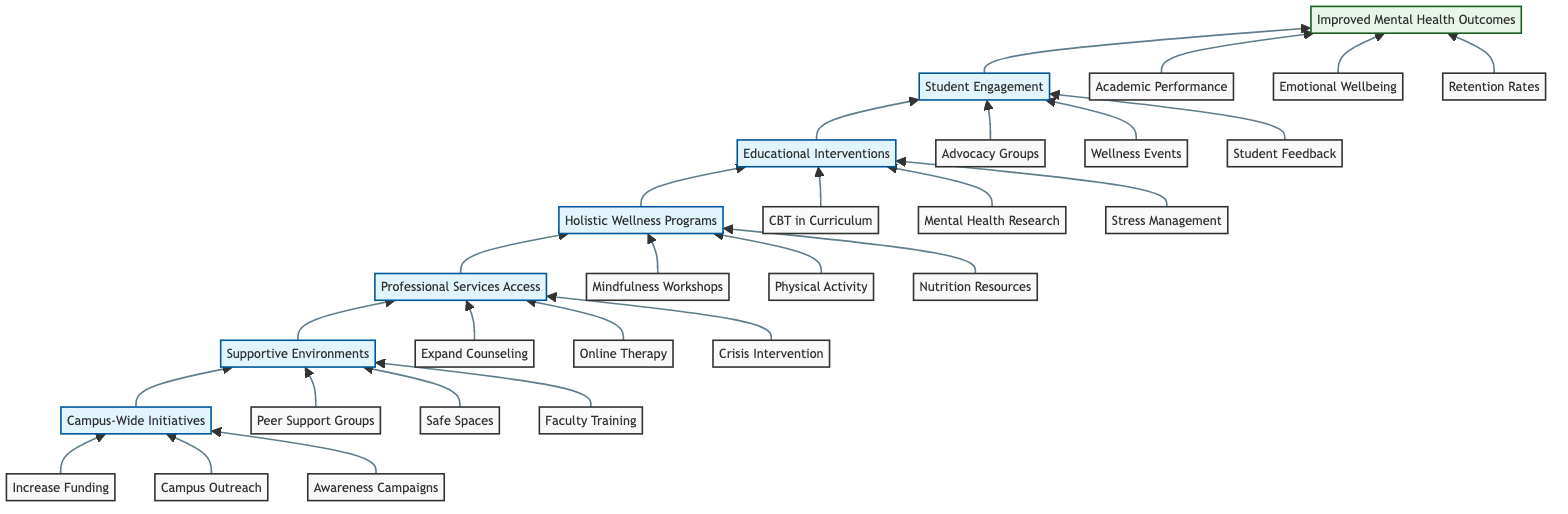What is the top node in the flow chart? The top node represents the ultimate goal of the flow chart and can be found at the highest position, which is “Improved Mental Health Outcomes.”
Answer: Improved Mental Health Outcomes How many components are listed under "Campus-Wide Initiatives"? To find the number of components, we can check the list provided under the "Campus-Wide Initiatives" node, which includes three components: Increase Funding for Mental Health Services, Implement Campus Outreach Programs, and Promote Mental Health Awareness Campaigns.
Answer: 3 Which node is immediately above "Student Engagement"? To determine the node immediately above "Student Engagement," you would look one level higher in the flow chart, and that node is "Educational Interventions."
Answer: Educational Interventions What are the components of "Professional Services Access"? By examining the components listed under the "Professional Services Access" node, we find three items: Expand Counseling Services, Improve Accessibility to Online Therapy, and Offer Crisis Intervention Services.
Answer: Expand Counseling Services, Improve Accessibility to Online Therapy, Offer Crisis Intervention Services How many levels are in this flow chart? Counting the total number of levels represented in the diagram, we see there are seven levels, ranging from Campus-Wide Initiatives at the bottom to Improved Mental Health Outcomes at the top.
Answer: 7 What relationship is established between "Holistic Wellness Programs" and "Supportive Environments"? The relationship can be identified by following the arrows, which indicate a flow of influence; specifically, "Supportive Environments" leads to "Holistic Wellness Programs," suggesting that the former is a precursor to implementing the latter.
Answer: Supportive Environments leads to Holistic Wellness Programs How many outcomes are listed under "Improved Mental Health Outcomes"? The outcomes can be found under the top node, where three distinct outcomes are specified: Increased Academic Performance, Enhanced Emotional Wellbeing, and Higher Retention and Graduation Rates.
Answer: 3 Which initiative has the component "Train Faculty in Mental Health First Aid"? To find the specific initiative, trace back from the component to its parent node; "Train Faculty in Mental Health First Aid" is listed under the "Supportive Environments" node, indicating it is part of that initiative.
Answer: Supportive Environments 